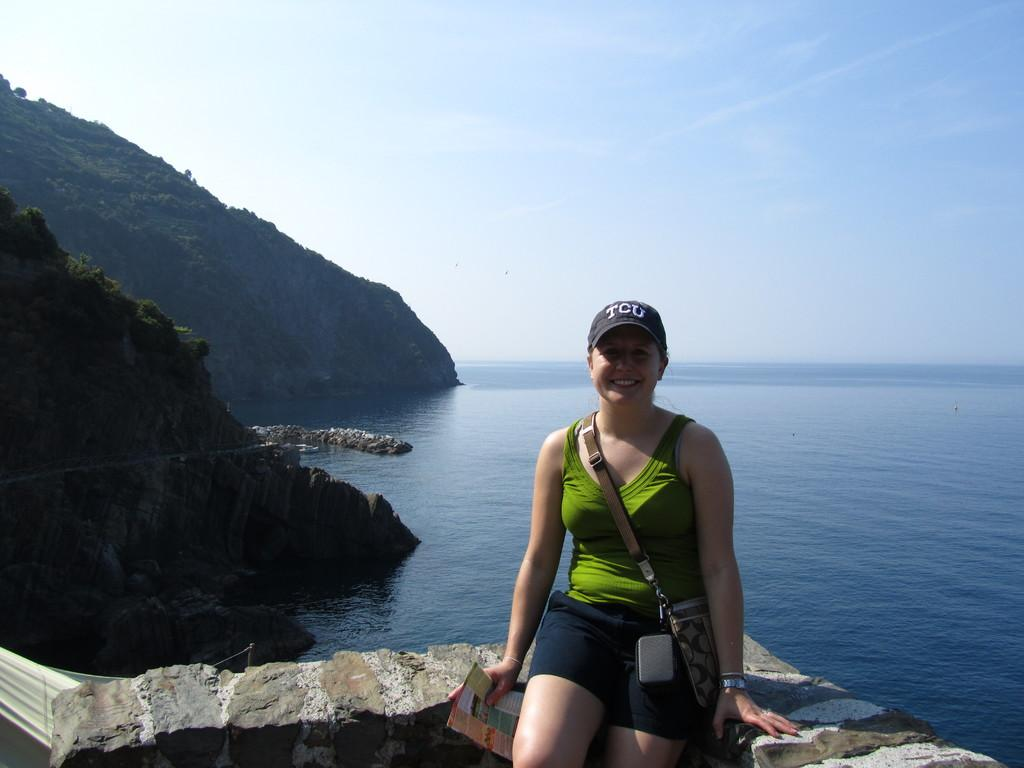Who is the main subject in the image? There is a woman in the image. What is the woman sitting on? The woman is sitting on a stone surface. What can be seen in the background of the image? There is a mountain in the background of the image. Is there any water visible in the image? Yes, there is a water surface beside the mountain. What type of fuel is the woman using to power her vehicle in the image? There is no vehicle present in the image, and therefore no fuel is being used. Can you tell me what letter the woman is holding in the image? There is no letter visible in the image. 